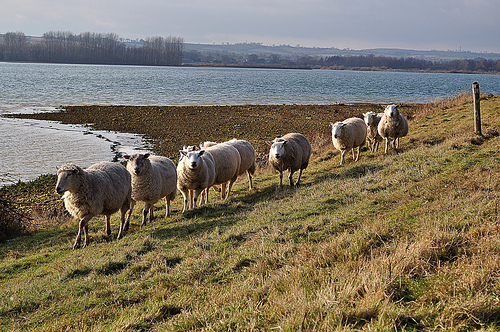<image>
Is there a cow on the road? No. The cow is not positioned on the road. They may be near each other, but the cow is not supported by or resting on top of the road. Where is the after in relation to the sheep? Is it on the sheep? No. The after is not positioned on the sheep. They may be near each other, but the after is not supported by or resting on top of the sheep. Where is the sheep in relation to the water? Is it in the water? No. The sheep is not contained within the water. These objects have a different spatial relationship. 